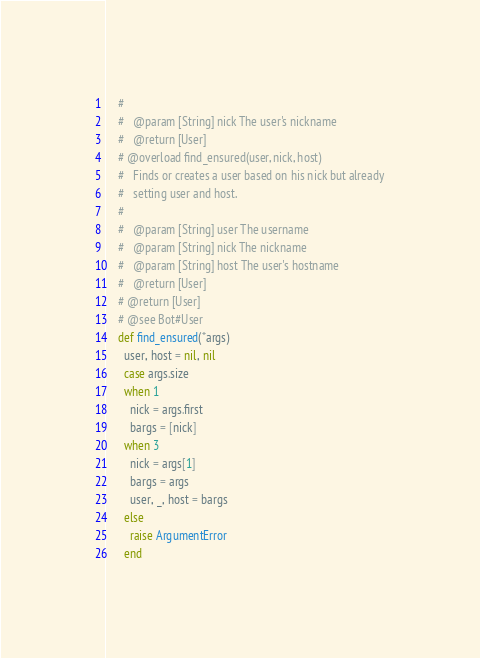Convert code to text. <code><loc_0><loc_0><loc_500><loc_500><_Ruby_>    #
    #   @param [String] nick The user's nickname
    #   @return [User]
    # @overload find_ensured(user, nick, host)
    #   Finds or creates a user based on his nick but already
    #   setting user and host.
    #
    #   @param [String] user The username
    #   @param [String] nick The nickname
    #   @param [String] host The user's hostname
    #   @return [User]
    # @return [User]
    # @see Bot#User
    def find_ensured(*args)
      user, host = nil, nil
      case args.size
      when 1
        nick = args.first
        bargs = [nick]
      when 3
        nick = args[1]
        bargs = args
        user, _, host = bargs
      else
        raise ArgumentError
      end</code> 